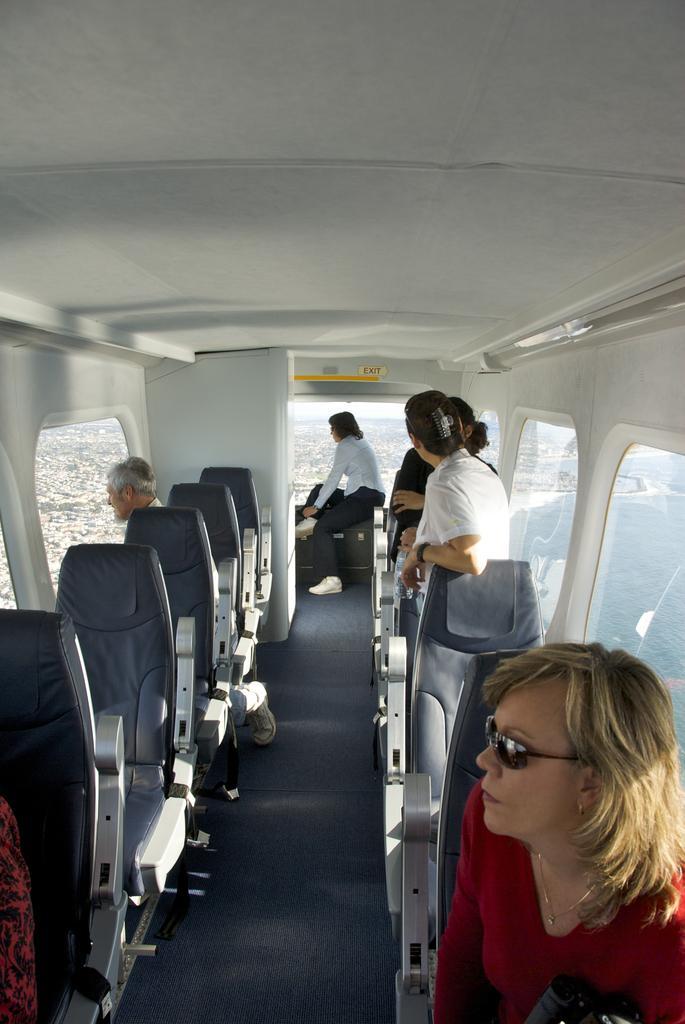Could you give a brief overview of what you see in this image? In this image there are group of persons sitting and standing and there are empty chairs on the left side and there are windows and outside the windows on the right side there is water and on the left side there are trees which are visible outside of the window. 